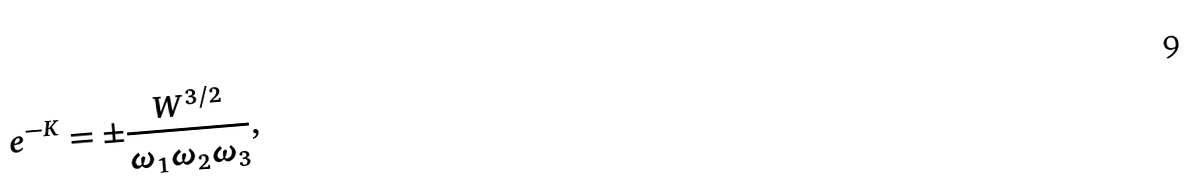<formula> <loc_0><loc_0><loc_500><loc_500>e ^ { - K } = \pm \frac { W ^ { 3 / 2 } } { \omega _ { 1 } \omega _ { 2 } \omega _ { 3 } } ,</formula> 